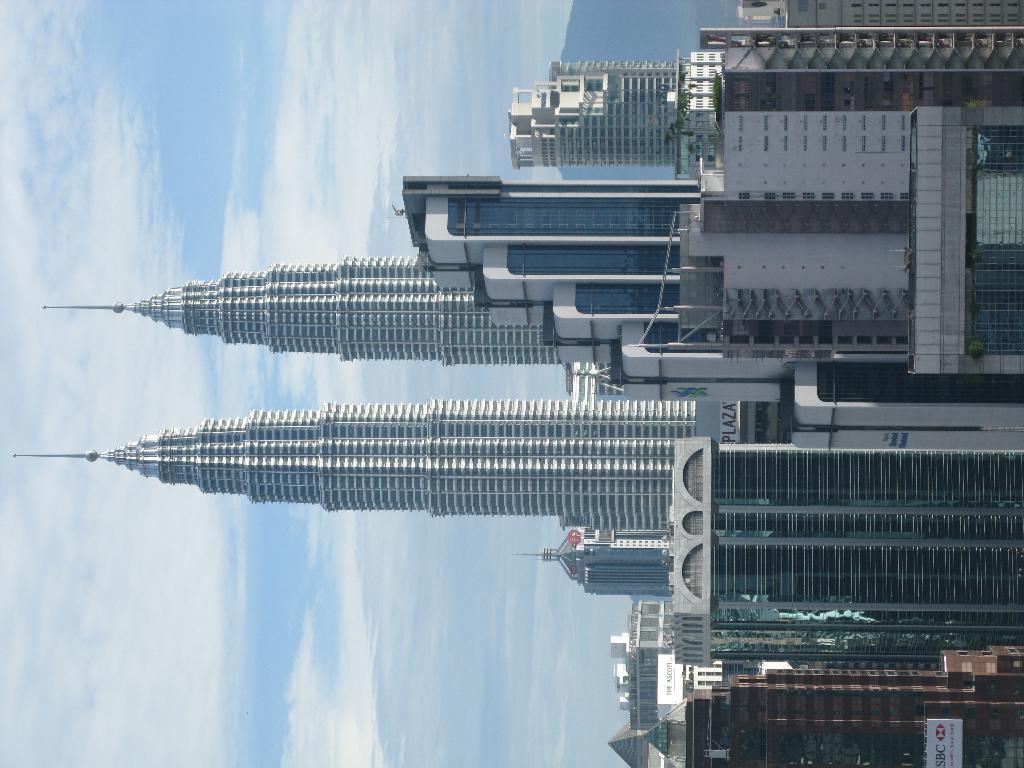Describe this image in one or two sentences. On the right side of the image we can see some buildings and towers. On the left side of the image we can see some clouds in the sky. 